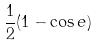<formula> <loc_0><loc_0><loc_500><loc_500>\frac { 1 } { 2 } ( 1 - \cos e )</formula> 